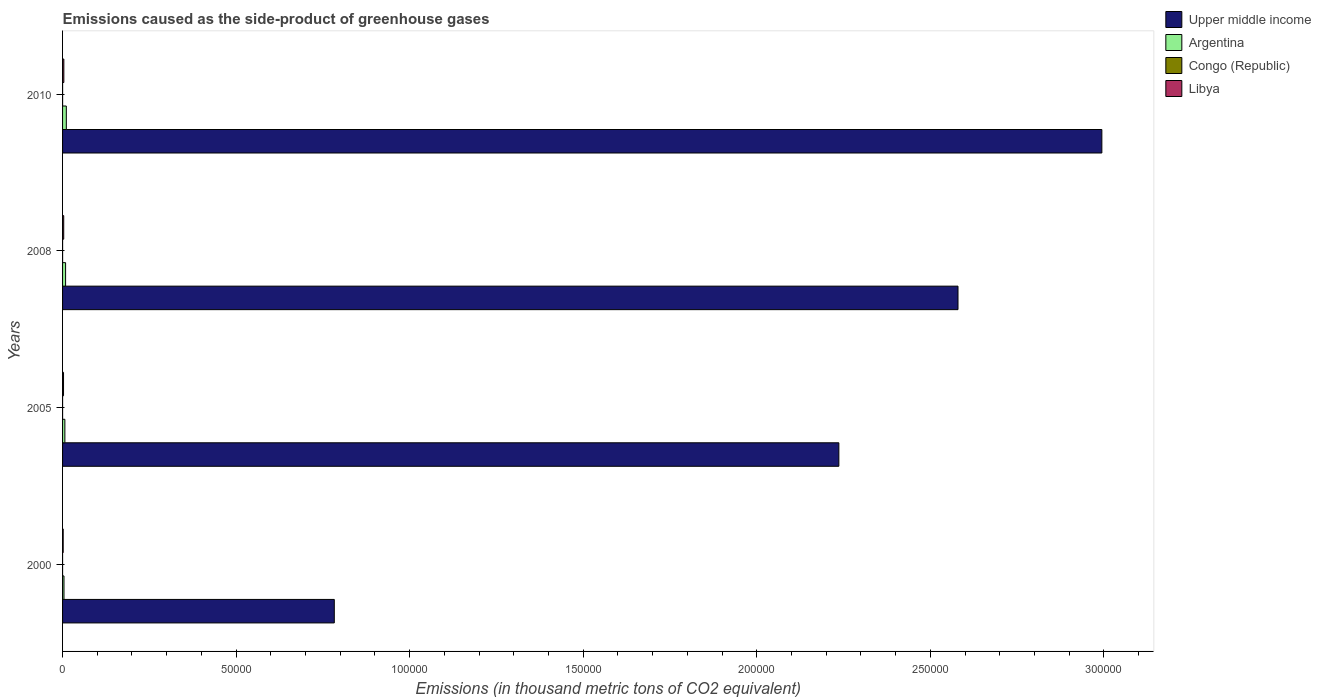Are the number of bars per tick equal to the number of legend labels?
Give a very brief answer. Yes. Are the number of bars on each tick of the Y-axis equal?
Provide a short and direct response. Yes. What is the label of the 1st group of bars from the top?
Your answer should be compact. 2010. What is the emissions caused as the side-product of greenhouse gases in Libya in 2008?
Ensure brevity in your answer.  331.5. Across all years, what is the maximum emissions caused as the side-product of greenhouse gases in Libya?
Provide a short and direct response. 366. Across all years, what is the minimum emissions caused as the side-product of greenhouse gases in Argentina?
Your answer should be compact. 408.8. What is the total emissions caused as the side-product of greenhouse gases in Congo (Republic) in the graph?
Your response must be concise. 20.2. What is the difference between the emissions caused as the side-product of greenhouse gases in Argentina in 2005 and that in 2010?
Provide a succinct answer. -419.1. What is the difference between the emissions caused as the side-product of greenhouse gases in Libya in 2005 and the emissions caused as the side-product of greenhouse gases in Upper middle income in 2000?
Your answer should be very brief. -7.80e+04. What is the average emissions caused as the side-product of greenhouse gases in Libya per year?
Your answer should be very brief. 289. In the year 2000, what is the difference between the emissions caused as the side-product of greenhouse gases in Argentina and emissions caused as the side-product of greenhouse gases in Upper middle income?
Keep it short and to the point. -7.79e+04. In how many years, is the emissions caused as the side-product of greenhouse gases in Congo (Republic) greater than 270000 thousand metric tons?
Offer a very short reply. 0. What is the ratio of the emissions caused as the side-product of greenhouse gases in Congo (Republic) in 2000 to that in 2005?
Provide a succinct answer. 0.17. Is the emissions caused as the side-product of greenhouse gases in Congo (Republic) in 2000 less than that in 2010?
Your answer should be compact. Yes. Is the difference between the emissions caused as the side-product of greenhouse gases in Argentina in 2000 and 2008 greater than the difference between the emissions caused as the side-product of greenhouse gases in Upper middle income in 2000 and 2008?
Offer a very short reply. Yes. What is the difference between the highest and the second highest emissions caused as the side-product of greenhouse gases in Upper middle income?
Your answer should be very brief. 4.14e+04. What is the difference between the highest and the lowest emissions caused as the side-product of greenhouse gases in Libya?
Your response must be concise. 187.8. What does the 4th bar from the top in 2010 represents?
Your answer should be compact. Upper middle income. What does the 3rd bar from the bottom in 2010 represents?
Offer a terse response. Congo (Republic). Is it the case that in every year, the sum of the emissions caused as the side-product of greenhouse gases in Argentina and emissions caused as the side-product of greenhouse gases in Libya is greater than the emissions caused as the side-product of greenhouse gases in Congo (Republic)?
Keep it short and to the point. Yes. How many bars are there?
Ensure brevity in your answer.  16. What is the difference between two consecutive major ticks on the X-axis?
Your answer should be very brief. 5.00e+04. Does the graph contain any zero values?
Ensure brevity in your answer.  No. What is the title of the graph?
Provide a succinct answer. Emissions caused as the side-product of greenhouse gases. Does "Tunisia" appear as one of the legend labels in the graph?
Provide a succinct answer. No. What is the label or title of the X-axis?
Keep it short and to the point. Emissions (in thousand metric tons of CO2 equivalent). What is the Emissions (in thousand metric tons of CO2 equivalent) in Upper middle income in 2000?
Give a very brief answer. 7.83e+04. What is the Emissions (in thousand metric tons of CO2 equivalent) of Argentina in 2000?
Give a very brief answer. 408.8. What is the Emissions (in thousand metric tons of CO2 equivalent) in Congo (Republic) in 2000?
Your response must be concise. 0.8. What is the Emissions (in thousand metric tons of CO2 equivalent) of Libya in 2000?
Ensure brevity in your answer.  178.2. What is the Emissions (in thousand metric tons of CO2 equivalent) in Upper middle income in 2005?
Offer a very short reply. 2.24e+05. What is the Emissions (in thousand metric tons of CO2 equivalent) of Argentina in 2005?
Offer a very short reply. 664.9. What is the Emissions (in thousand metric tons of CO2 equivalent) of Congo (Republic) in 2005?
Provide a succinct answer. 4.7. What is the Emissions (in thousand metric tons of CO2 equivalent) of Libya in 2005?
Keep it short and to the point. 280.3. What is the Emissions (in thousand metric tons of CO2 equivalent) of Upper middle income in 2008?
Offer a very short reply. 2.58e+05. What is the Emissions (in thousand metric tons of CO2 equivalent) of Argentina in 2008?
Your answer should be compact. 872.4. What is the Emissions (in thousand metric tons of CO2 equivalent) of Libya in 2008?
Your answer should be very brief. 331.5. What is the Emissions (in thousand metric tons of CO2 equivalent) in Upper middle income in 2010?
Give a very brief answer. 2.99e+05. What is the Emissions (in thousand metric tons of CO2 equivalent) in Argentina in 2010?
Give a very brief answer. 1084. What is the Emissions (in thousand metric tons of CO2 equivalent) in Congo (Republic) in 2010?
Provide a short and direct response. 8. What is the Emissions (in thousand metric tons of CO2 equivalent) of Libya in 2010?
Give a very brief answer. 366. Across all years, what is the maximum Emissions (in thousand metric tons of CO2 equivalent) in Upper middle income?
Make the answer very short. 2.99e+05. Across all years, what is the maximum Emissions (in thousand metric tons of CO2 equivalent) of Argentina?
Provide a succinct answer. 1084. Across all years, what is the maximum Emissions (in thousand metric tons of CO2 equivalent) in Congo (Republic)?
Offer a very short reply. 8. Across all years, what is the maximum Emissions (in thousand metric tons of CO2 equivalent) of Libya?
Provide a short and direct response. 366. Across all years, what is the minimum Emissions (in thousand metric tons of CO2 equivalent) in Upper middle income?
Keep it short and to the point. 7.83e+04. Across all years, what is the minimum Emissions (in thousand metric tons of CO2 equivalent) of Argentina?
Your answer should be compact. 408.8. Across all years, what is the minimum Emissions (in thousand metric tons of CO2 equivalent) of Congo (Republic)?
Offer a terse response. 0.8. Across all years, what is the minimum Emissions (in thousand metric tons of CO2 equivalent) of Libya?
Provide a short and direct response. 178.2. What is the total Emissions (in thousand metric tons of CO2 equivalent) in Upper middle income in the graph?
Offer a very short reply. 8.59e+05. What is the total Emissions (in thousand metric tons of CO2 equivalent) of Argentina in the graph?
Provide a succinct answer. 3030.1. What is the total Emissions (in thousand metric tons of CO2 equivalent) in Congo (Republic) in the graph?
Offer a very short reply. 20.2. What is the total Emissions (in thousand metric tons of CO2 equivalent) in Libya in the graph?
Offer a very short reply. 1156. What is the difference between the Emissions (in thousand metric tons of CO2 equivalent) of Upper middle income in 2000 and that in 2005?
Provide a succinct answer. -1.45e+05. What is the difference between the Emissions (in thousand metric tons of CO2 equivalent) in Argentina in 2000 and that in 2005?
Your answer should be very brief. -256.1. What is the difference between the Emissions (in thousand metric tons of CO2 equivalent) of Libya in 2000 and that in 2005?
Make the answer very short. -102.1. What is the difference between the Emissions (in thousand metric tons of CO2 equivalent) of Upper middle income in 2000 and that in 2008?
Your answer should be very brief. -1.80e+05. What is the difference between the Emissions (in thousand metric tons of CO2 equivalent) of Argentina in 2000 and that in 2008?
Offer a very short reply. -463.6. What is the difference between the Emissions (in thousand metric tons of CO2 equivalent) in Congo (Republic) in 2000 and that in 2008?
Ensure brevity in your answer.  -5.9. What is the difference between the Emissions (in thousand metric tons of CO2 equivalent) in Libya in 2000 and that in 2008?
Provide a short and direct response. -153.3. What is the difference between the Emissions (in thousand metric tons of CO2 equivalent) in Upper middle income in 2000 and that in 2010?
Make the answer very short. -2.21e+05. What is the difference between the Emissions (in thousand metric tons of CO2 equivalent) of Argentina in 2000 and that in 2010?
Keep it short and to the point. -675.2. What is the difference between the Emissions (in thousand metric tons of CO2 equivalent) in Congo (Republic) in 2000 and that in 2010?
Provide a short and direct response. -7.2. What is the difference between the Emissions (in thousand metric tons of CO2 equivalent) of Libya in 2000 and that in 2010?
Provide a succinct answer. -187.8. What is the difference between the Emissions (in thousand metric tons of CO2 equivalent) in Upper middle income in 2005 and that in 2008?
Keep it short and to the point. -3.43e+04. What is the difference between the Emissions (in thousand metric tons of CO2 equivalent) in Argentina in 2005 and that in 2008?
Your answer should be very brief. -207.5. What is the difference between the Emissions (in thousand metric tons of CO2 equivalent) in Libya in 2005 and that in 2008?
Provide a short and direct response. -51.2. What is the difference between the Emissions (in thousand metric tons of CO2 equivalent) in Upper middle income in 2005 and that in 2010?
Provide a succinct answer. -7.58e+04. What is the difference between the Emissions (in thousand metric tons of CO2 equivalent) of Argentina in 2005 and that in 2010?
Keep it short and to the point. -419.1. What is the difference between the Emissions (in thousand metric tons of CO2 equivalent) of Congo (Republic) in 2005 and that in 2010?
Your answer should be compact. -3.3. What is the difference between the Emissions (in thousand metric tons of CO2 equivalent) in Libya in 2005 and that in 2010?
Your response must be concise. -85.7. What is the difference between the Emissions (in thousand metric tons of CO2 equivalent) of Upper middle income in 2008 and that in 2010?
Ensure brevity in your answer.  -4.14e+04. What is the difference between the Emissions (in thousand metric tons of CO2 equivalent) of Argentina in 2008 and that in 2010?
Your answer should be very brief. -211.6. What is the difference between the Emissions (in thousand metric tons of CO2 equivalent) of Libya in 2008 and that in 2010?
Give a very brief answer. -34.5. What is the difference between the Emissions (in thousand metric tons of CO2 equivalent) in Upper middle income in 2000 and the Emissions (in thousand metric tons of CO2 equivalent) in Argentina in 2005?
Make the answer very short. 7.76e+04. What is the difference between the Emissions (in thousand metric tons of CO2 equivalent) of Upper middle income in 2000 and the Emissions (in thousand metric tons of CO2 equivalent) of Congo (Republic) in 2005?
Provide a short and direct response. 7.83e+04. What is the difference between the Emissions (in thousand metric tons of CO2 equivalent) in Upper middle income in 2000 and the Emissions (in thousand metric tons of CO2 equivalent) in Libya in 2005?
Provide a short and direct response. 7.80e+04. What is the difference between the Emissions (in thousand metric tons of CO2 equivalent) of Argentina in 2000 and the Emissions (in thousand metric tons of CO2 equivalent) of Congo (Republic) in 2005?
Keep it short and to the point. 404.1. What is the difference between the Emissions (in thousand metric tons of CO2 equivalent) of Argentina in 2000 and the Emissions (in thousand metric tons of CO2 equivalent) of Libya in 2005?
Give a very brief answer. 128.5. What is the difference between the Emissions (in thousand metric tons of CO2 equivalent) of Congo (Republic) in 2000 and the Emissions (in thousand metric tons of CO2 equivalent) of Libya in 2005?
Offer a very short reply. -279.5. What is the difference between the Emissions (in thousand metric tons of CO2 equivalent) of Upper middle income in 2000 and the Emissions (in thousand metric tons of CO2 equivalent) of Argentina in 2008?
Offer a terse response. 7.74e+04. What is the difference between the Emissions (in thousand metric tons of CO2 equivalent) in Upper middle income in 2000 and the Emissions (in thousand metric tons of CO2 equivalent) in Congo (Republic) in 2008?
Your answer should be very brief. 7.83e+04. What is the difference between the Emissions (in thousand metric tons of CO2 equivalent) of Upper middle income in 2000 and the Emissions (in thousand metric tons of CO2 equivalent) of Libya in 2008?
Provide a succinct answer. 7.80e+04. What is the difference between the Emissions (in thousand metric tons of CO2 equivalent) of Argentina in 2000 and the Emissions (in thousand metric tons of CO2 equivalent) of Congo (Republic) in 2008?
Offer a very short reply. 402.1. What is the difference between the Emissions (in thousand metric tons of CO2 equivalent) of Argentina in 2000 and the Emissions (in thousand metric tons of CO2 equivalent) of Libya in 2008?
Provide a short and direct response. 77.3. What is the difference between the Emissions (in thousand metric tons of CO2 equivalent) of Congo (Republic) in 2000 and the Emissions (in thousand metric tons of CO2 equivalent) of Libya in 2008?
Make the answer very short. -330.7. What is the difference between the Emissions (in thousand metric tons of CO2 equivalent) in Upper middle income in 2000 and the Emissions (in thousand metric tons of CO2 equivalent) in Argentina in 2010?
Ensure brevity in your answer.  7.72e+04. What is the difference between the Emissions (in thousand metric tons of CO2 equivalent) of Upper middle income in 2000 and the Emissions (in thousand metric tons of CO2 equivalent) of Congo (Republic) in 2010?
Your answer should be very brief. 7.83e+04. What is the difference between the Emissions (in thousand metric tons of CO2 equivalent) in Upper middle income in 2000 and the Emissions (in thousand metric tons of CO2 equivalent) in Libya in 2010?
Your answer should be compact. 7.79e+04. What is the difference between the Emissions (in thousand metric tons of CO2 equivalent) of Argentina in 2000 and the Emissions (in thousand metric tons of CO2 equivalent) of Congo (Republic) in 2010?
Provide a succinct answer. 400.8. What is the difference between the Emissions (in thousand metric tons of CO2 equivalent) of Argentina in 2000 and the Emissions (in thousand metric tons of CO2 equivalent) of Libya in 2010?
Give a very brief answer. 42.8. What is the difference between the Emissions (in thousand metric tons of CO2 equivalent) in Congo (Republic) in 2000 and the Emissions (in thousand metric tons of CO2 equivalent) in Libya in 2010?
Make the answer very short. -365.2. What is the difference between the Emissions (in thousand metric tons of CO2 equivalent) in Upper middle income in 2005 and the Emissions (in thousand metric tons of CO2 equivalent) in Argentina in 2008?
Keep it short and to the point. 2.23e+05. What is the difference between the Emissions (in thousand metric tons of CO2 equivalent) of Upper middle income in 2005 and the Emissions (in thousand metric tons of CO2 equivalent) of Congo (Republic) in 2008?
Give a very brief answer. 2.24e+05. What is the difference between the Emissions (in thousand metric tons of CO2 equivalent) of Upper middle income in 2005 and the Emissions (in thousand metric tons of CO2 equivalent) of Libya in 2008?
Give a very brief answer. 2.23e+05. What is the difference between the Emissions (in thousand metric tons of CO2 equivalent) in Argentina in 2005 and the Emissions (in thousand metric tons of CO2 equivalent) in Congo (Republic) in 2008?
Offer a very short reply. 658.2. What is the difference between the Emissions (in thousand metric tons of CO2 equivalent) in Argentina in 2005 and the Emissions (in thousand metric tons of CO2 equivalent) in Libya in 2008?
Provide a succinct answer. 333.4. What is the difference between the Emissions (in thousand metric tons of CO2 equivalent) in Congo (Republic) in 2005 and the Emissions (in thousand metric tons of CO2 equivalent) in Libya in 2008?
Offer a terse response. -326.8. What is the difference between the Emissions (in thousand metric tons of CO2 equivalent) of Upper middle income in 2005 and the Emissions (in thousand metric tons of CO2 equivalent) of Argentina in 2010?
Give a very brief answer. 2.23e+05. What is the difference between the Emissions (in thousand metric tons of CO2 equivalent) of Upper middle income in 2005 and the Emissions (in thousand metric tons of CO2 equivalent) of Congo (Republic) in 2010?
Offer a very short reply. 2.24e+05. What is the difference between the Emissions (in thousand metric tons of CO2 equivalent) of Upper middle income in 2005 and the Emissions (in thousand metric tons of CO2 equivalent) of Libya in 2010?
Provide a short and direct response. 2.23e+05. What is the difference between the Emissions (in thousand metric tons of CO2 equivalent) in Argentina in 2005 and the Emissions (in thousand metric tons of CO2 equivalent) in Congo (Republic) in 2010?
Keep it short and to the point. 656.9. What is the difference between the Emissions (in thousand metric tons of CO2 equivalent) in Argentina in 2005 and the Emissions (in thousand metric tons of CO2 equivalent) in Libya in 2010?
Provide a short and direct response. 298.9. What is the difference between the Emissions (in thousand metric tons of CO2 equivalent) of Congo (Republic) in 2005 and the Emissions (in thousand metric tons of CO2 equivalent) of Libya in 2010?
Your answer should be compact. -361.3. What is the difference between the Emissions (in thousand metric tons of CO2 equivalent) of Upper middle income in 2008 and the Emissions (in thousand metric tons of CO2 equivalent) of Argentina in 2010?
Your answer should be compact. 2.57e+05. What is the difference between the Emissions (in thousand metric tons of CO2 equivalent) in Upper middle income in 2008 and the Emissions (in thousand metric tons of CO2 equivalent) in Congo (Republic) in 2010?
Make the answer very short. 2.58e+05. What is the difference between the Emissions (in thousand metric tons of CO2 equivalent) in Upper middle income in 2008 and the Emissions (in thousand metric tons of CO2 equivalent) in Libya in 2010?
Your answer should be very brief. 2.58e+05. What is the difference between the Emissions (in thousand metric tons of CO2 equivalent) in Argentina in 2008 and the Emissions (in thousand metric tons of CO2 equivalent) in Congo (Republic) in 2010?
Your answer should be very brief. 864.4. What is the difference between the Emissions (in thousand metric tons of CO2 equivalent) in Argentina in 2008 and the Emissions (in thousand metric tons of CO2 equivalent) in Libya in 2010?
Offer a terse response. 506.4. What is the difference between the Emissions (in thousand metric tons of CO2 equivalent) in Congo (Republic) in 2008 and the Emissions (in thousand metric tons of CO2 equivalent) in Libya in 2010?
Your response must be concise. -359.3. What is the average Emissions (in thousand metric tons of CO2 equivalent) in Upper middle income per year?
Offer a very short reply. 2.15e+05. What is the average Emissions (in thousand metric tons of CO2 equivalent) of Argentina per year?
Provide a short and direct response. 757.52. What is the average Emissions (in thousand metric tons of CO2 equivalent) in Congo (Republic) per year?
Provide a short and direct response. 5.05. What is the average Emissions (in thousand metric tons of CO2 equivalent) of Libya per year?
Keep it short and to the point. 289. In the year 2000, what is the difference between the Emissions (in thousand metric tons of CO2 equivalent) in Upper middle income and Emissions (in thousand metric tons of CO2 equivalent) in Argentina?
Give a very brief answer. 7.79e+04. In the year 2000, what is the difference between the Emissions (in thousand metric tons of CO2 equivalent) of Upper middle income and Emissions (in thousand metric tons of CO2 equivalent) of Congo (Republic)?
Give a very brief answer. 7.83e+04. In the year 2000, what is the difference between the Emissions (in thousand metric tons of CO2 equivalent) in Upper middle income and Emissions (in thousand metric tons of CO2 equivalent) in Libya?
Make the answer very short. 7.81e+04. In the year 2000, what is the difference between the Emissions (in thousand metric tons of CO2 equivalent) in Argentina and Emissions (in thousand metric tons of CO2 equivalent) in Congo (Republic)?
Offer a very short reply. 408. In the year 2000, what is the difference between the Emissions (in thousand metric tons of CO2 equivalent) of Argentina and Emissions (in thousand metric tons of CO2 equivalent) of Libya?
Make the answer very short. 230.6. In the year 2000, what is the difference between the Emissions (in thousand metric tons of CO2 equivalent) in Congo (Republic) and Emissions (in thousand metric tons of CO2 equivalent) in Libya?
Give a very brief answer. -177.4. In the year 2005, what is the difference between the Emissions (in thousand metric tons of CO2 equivalent) of Upper middle income and Emissions (in thousand metric tons of CO2 equivalent) of Argentina?
Provide a succinct answer. 2.23e+05. In the year 2005, what is the difference between the Emissions (in thousand metric tons of CO2 equivalent) of Upper middle income and Emissions (in thousand metric tons of CO2 equivalent) of Congo (Republic)?
Keep it short and to the point. 2.24e+05. In the year 2005, what is the difference between the Emissions (in thousand metric tons of CO2 equivalent) of Upper middle income and Emissions (in thousand metric tons of CO2 equivalent) of Libya?
Keep it short and to the point. 2.23e+05. In the year 2005, what is the difference between the Emissions (in thousand metric tons of CO2 equivalent) in Argentina and Emissions (in thousand metric tons of CO2 equivalent) in Congo (Republic)?
Provide a short and direct response. 660.2. In the year 2005, what is the difference between the Emissions (in thousand metric tons of CO2 equivalent) of Argentina and Emissions (in thousand metric tons of CO2 equivalent) of Libya?
Provide a succinct answer. 384.6. In the year 2005, what is the difference between the Emissions (in thousand metric tons of CO2 equivalent) of Congo (Republic) and Emissions (in thousand metric tons of CO2 equivalent) of Libya?
Provide a succinct answer. -275.6. In the year 2008, what is the difference between the Emissions (in thousand metric tons of CO2 equivalent) in Upper middle income and Emissions (in thousand metric tons of CO2 equivalent) in Argentina?
Keep it short and to the point. 2.57e+05. In the year 2008, what is the difference between the Emissions (in thousand metric tons of CO2 equivalent) of Upper middle income and Emissions (in thousand metric tons of CO2 equivalent) of Congo (Republic)?
Offer a very short reply. 2.58e+05. In the year 2008, what is the difference between the Emissions (in thousand metric tons of CO2 equivalent) of Upper middle income and Emissions (in thousand metric tons of CO2 equivalent) of Libya?
Give a very brief answer. 2.58e+05. In the year 2008, what is the difference between the Emissions (in thousand metric tons of CO2 equivalent) in Argentina and Emissions (in thousand metric tons of CO2 equivalent) in Congo (Republic)?
Provide a succinct answer. 865.7. In the year 2008, what is the difference between the Emissions (in thousand metric tons of CO2 equivalent) in Argentina and Emissions (in thousand metric tons of CO2 equivalent) in Libya?
Provide a short and direct response. 540.9. In the year 2008, what is the difference between the Emissions (in thousand metric tons of CO2 equivalent) of Congo (Republic) and Emissions (in thousand metric tons of CO2 equivalent) of Libya?
Your response must be concise. -324.8. In the year 2010, what is the difference between the Emissions (in thousand metric tons of CO2 equivalent) in Upper middle income and Emissions (in thousand metric tons of CO2 equivalent) in Argentina?
Offer a very short reply. 2.98e+05. In the year 2010, what is the difference between the Emissions (in thousand metric tons of CO2 equivalent) of Upper middle income and Emissions (in thousand metric tons of CO2 equivalent) of Congo (Republic)?
Give a very brief answer. 2.99e+05. In the year 2010, what is the difference between the Emissions (in thousand metric tons of CO2 equivalent) in Upper middle income and Emissions (in thousand metric tons of CO2 equivalent) in Libya?
Offer a terse response. 2.99e+05. In the year 2010, what is the difference between the Emissions (in thousand metric tons of CO2 equivalent) of Argentina and Emissions (in thousand metric tons of CO2 equivalent) of Congo (Republic)?
Give a very brief answer. 1076. In the year 2010, what is the difference between the Emissions (in thousand metric tons of CO2 equivalent) of Argentina and Emissions (in thousand metric tons of CO2 equivalent) of Libya?
Provide a short and direct response. 718. In the year 2010, what is the difference between the Emissions (in thousand metric tons of CO2 equivalent) of Congo (Republic) and Emissions (in thousand metric tons of CO2 equivalent) of Libya?
Offer a very short reply. -358. What is the ratio of the Emissions (in thousand metric tons of CO2 equivalent) of Upper middle income in 2000 to that in 2005?
Your answer should be very brief. 0.35. What is the ratio of the Emissions (in thousand metric tons of CO2 equivalent) of Argentina in 2000 to that in 2005?
Your answer should be very brief. 0.61. What is the ratio of the Emissions (in thousand metric tons of CO2 equivalent) of Congo (Republic) in 2000 to that in 2005?
Your answer should be compact. 0.17. What is the ratio of the Emissions (in thousand metric tons of CO2 equivalent) of Libya in 2000 to that in 2005?
Your response must be concise. 0.64. What is the ratio of the Emissions (in thousand metric tons of CO2 equivalent) of Upper middle income in 2000 to that in 2008?
Your answer should be very brief. 0.3. What is the ratio of the Emissions (in thousand metric tons of CO2 equivalent) in Argentina in 2000 to that in 2008?
Give a very brief answer. 0.47. What is the ratio of the Emissions (in thousand metric tons of CO2 equivalent) of Congo (Republic) in 2000 to that in 2008?
Offer a terse response. 0.12. What is the ratio of the Emissions (in thousand metric tons of CO2 equivalent) of Libya in 2000 to that in 2008?
Provide a succinct answer. 0.54. What is the ratio of the Emissions (in thousand metric tons of CO2 equivalent) of Upper middle income in 2000 to that in 2010?
Ensure brevity in your answer.  0.26. What is the ratio of the Emissions (in thousand metric tons of CO2 equivalent) of Argentina in 2000 to that in 2010?
Keep it short and to the point. 0.38. What is the ratio of the Emissions (in thousand metric tons of CO2 equivalent) in Congo (Republic) in 2000 to that in 2010?
Make the answer very short. 0.1. What is the ratio of the Emissions (in thousand metric tons of CO2 equivalent) in Libya in 2000 to that in 2010?
Keep it short and to the point. 0.49. What is the ratio of the Emissions (in thousand metric tons of CO2 equivalent) of Upper middle income in 2005 to that in 2008?
Give a very brief answer. 0.87. What is the ratio of the Emissions (in thousand metric tons of CO2 equivalent) of Argentina in 2005 to that in 2008?
Give a very brief answer. 0.76. What is the ratio of the Emissions (in thousand metric tons of CO2 equivalent) of Congo (Republic) in 2005 to that in 2008?
Keep it short and to the point. 0.7. What is the ratio of the Emissions (in thousand metric tons of CO2 equivalent) in Libya in 2005 to that in 2008?
Offer a very short reply. 0.85. What is the ratio of the Emissions (in thousand metric tons of CO2 equivalent) in Upper middle income in 2005 to that in 2010?
Provide a short and direct response. 0.75. What is the ratio of the Emissions (in thousand metric tons of CO2 equivalent) of Argentina in 2005 to that in 2010?
Provide a short and direct response. 0.61. What is the ratio of the Emissions (in thousand metric tons of CO2 equivalent) of Congo (Republic) in 2005 to that in 2010?
Your answer should be very brief. 0.59. What is the ratio of the Emissions (in thousand metric tons of CO2 equivalent) in Libya in 2005 to that in 2010?
Offer a terse response. 0.77. What is the ratio of the Emissions (in thousand metric tons of CO2 equivalent) in Upper middle income in 2008 to that in 2010?
Your answer should be very brief. 0.86. What is the ratio of the Emissions (in thousand metric tons of CO2 equivalent) in Argentina in 2008 to that in 2010?
Offer a terse response. 0.8. What is the ratio of the Emissions (in thousand metric tons of CO2 equivalent) in Congo (Republic) in 2008 to that in 2010?
Offer a terse response. 0.84. What is the ratio of the Emissions (in thousand metric tons of CO2 equivalent) of Libya in 2008 to that in 2010?
Your answer should be compact. 0.91. What is the difference between the highest and the second highest Emissions (in thousand metric tons of CO2 equivalent) of Upper middle income?
Your answer should be compact. 4.14e+04. What is the difference between the highest and the second highest Emissions (in thousand metric tons of CO2 equivalent) in Argentina?
Offer a terse response. 211.6. What is the difference between the highest and the second highest Emissions (in thousand metric tons of CO2 equivalent) of Congo (Republic)?
Make the answer very short. 1.3. What is the difference between the highest and the second highest Emissions (in thousand metric tons of CO2 equivalent) of Libya?
Ensure brevity in your answer.  34.5. What is the difference between the highest and the lowest Emissions (in thousand metric tons of CO2 equivalent) in Upper middle income?
Offer a very short reply. 2.21e+05. What is the difference between the highest and the lowest Emissions (in thousand metric tons of CO2 equivalent) in Argentina?
Your answer should be very brief. 675.2. What is the difference between the highest and the lowest Emissions (in thousand metric tons of CO2 equivalent) of Libya?
Provide a succinct answer. 187.8. 